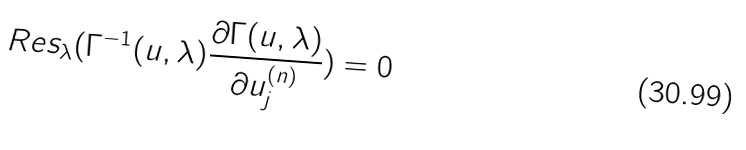<formula> <loc_0><loc_0><loc_500><loc_500>R e s _ { \lambda } ( \Gamma ^ { - 1 } ( u , \lambda ) \frac { \partial \Gamma ( u , \lambda ) } { \partial u _ { j } ^ { ( n ) } } ) = 0</formula> 